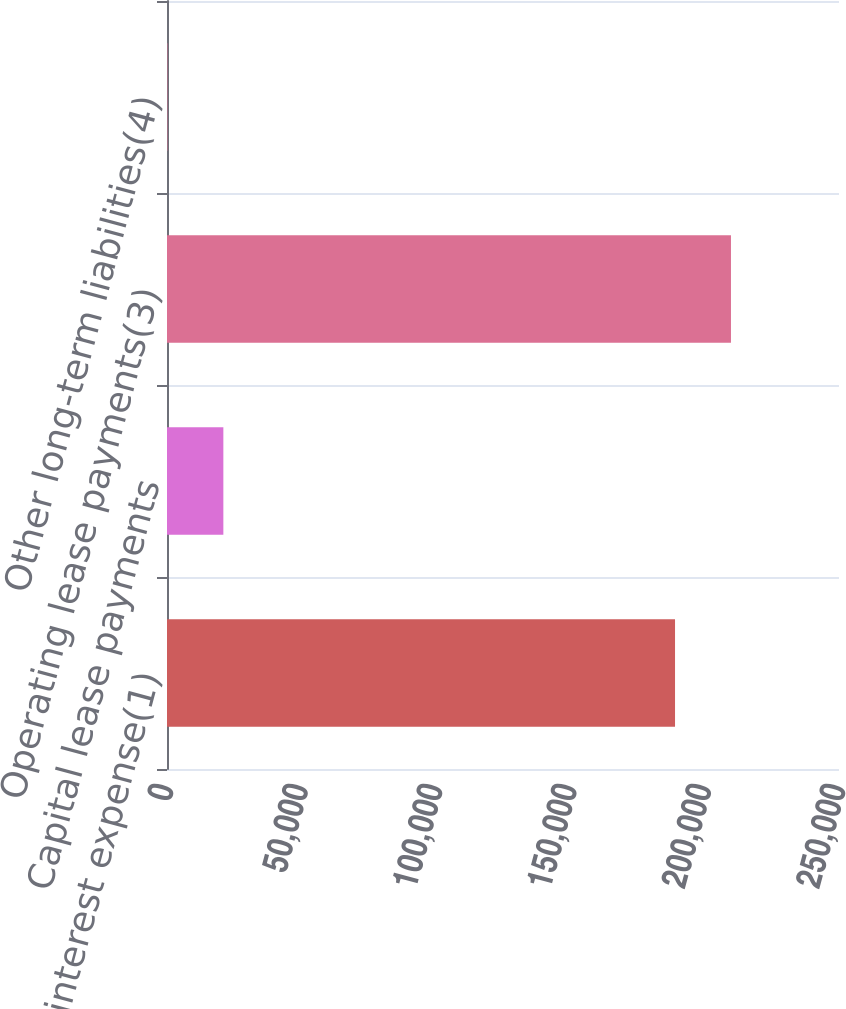Convert chart. <chart><loc_0><loc_0><loc_500><loc_500><bar_chart><fcel>Cash interest expense(1)<fcel>Capital lease payments<fcel>Operating lease payments(3)<fcel>Other long-term liabilities(4)<nl><fcel>189000<fcel>20965.2<fcel>209810<fcel>155<nl></chart> 